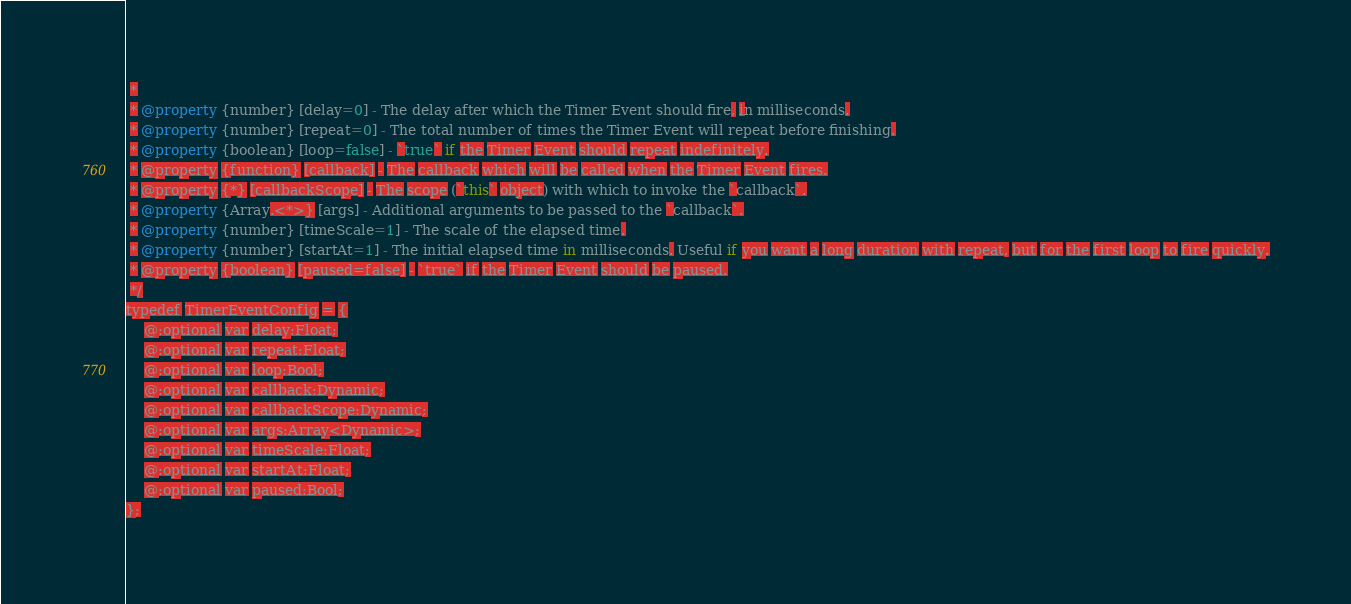Convert code to text. <code><loc_0><loc_0><loc_500><loc_500><_Haxe_> *
 * @property {number} [delay=0] - The delay after which the Timer Event should fire, in milliseconds.
 * @property {number} [repeat=0] - The total number of times the Timer Event will repeat before finishing.
 * @property {boolean} [loop=false] - `true` if the Timer Event should repeat indefinitely.
 * @property {function} [callback] - The callback which will be called when the Timer Event fires.
 * @property {*} [callbackScope] - The scope (`this` object) with which to invoke the `callback`.
 * @property {Array.<*>} [args] - Additional arguments to be passed to the `callback`.
 * @property {number} [timeScale=1] - The scale of the elapsed time.
 * @property {number} [startAt=1] - The initial elapsed time in milliseconds. Useful if you want a long duration with repeat, but for the first loop to fire quickly.
 * @property {boolean} [paused=false] - `true` if the Timer Event should be paused.
 */
typedef TimerEventConfig = {
    @:optional var delay:Float;
    @:optional var repeat:Float;
    @:optional var loop:Bool;
    @:optional var callback:Dynamic;
    @:optional var callbackScope:Dynamic;
    @:optional var args:Array<Dynamic>;
    @:optional var timeScale:Float;
    @:optional var startAt:Float;
    @:optional var paused:Bool;
};
</code> 